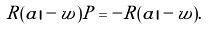Convert formula to latex. <formula><loc_0><loc_0><loc_500><loc_500>R ( a | - w ) P = - R ( a | - w ) .</formula> 